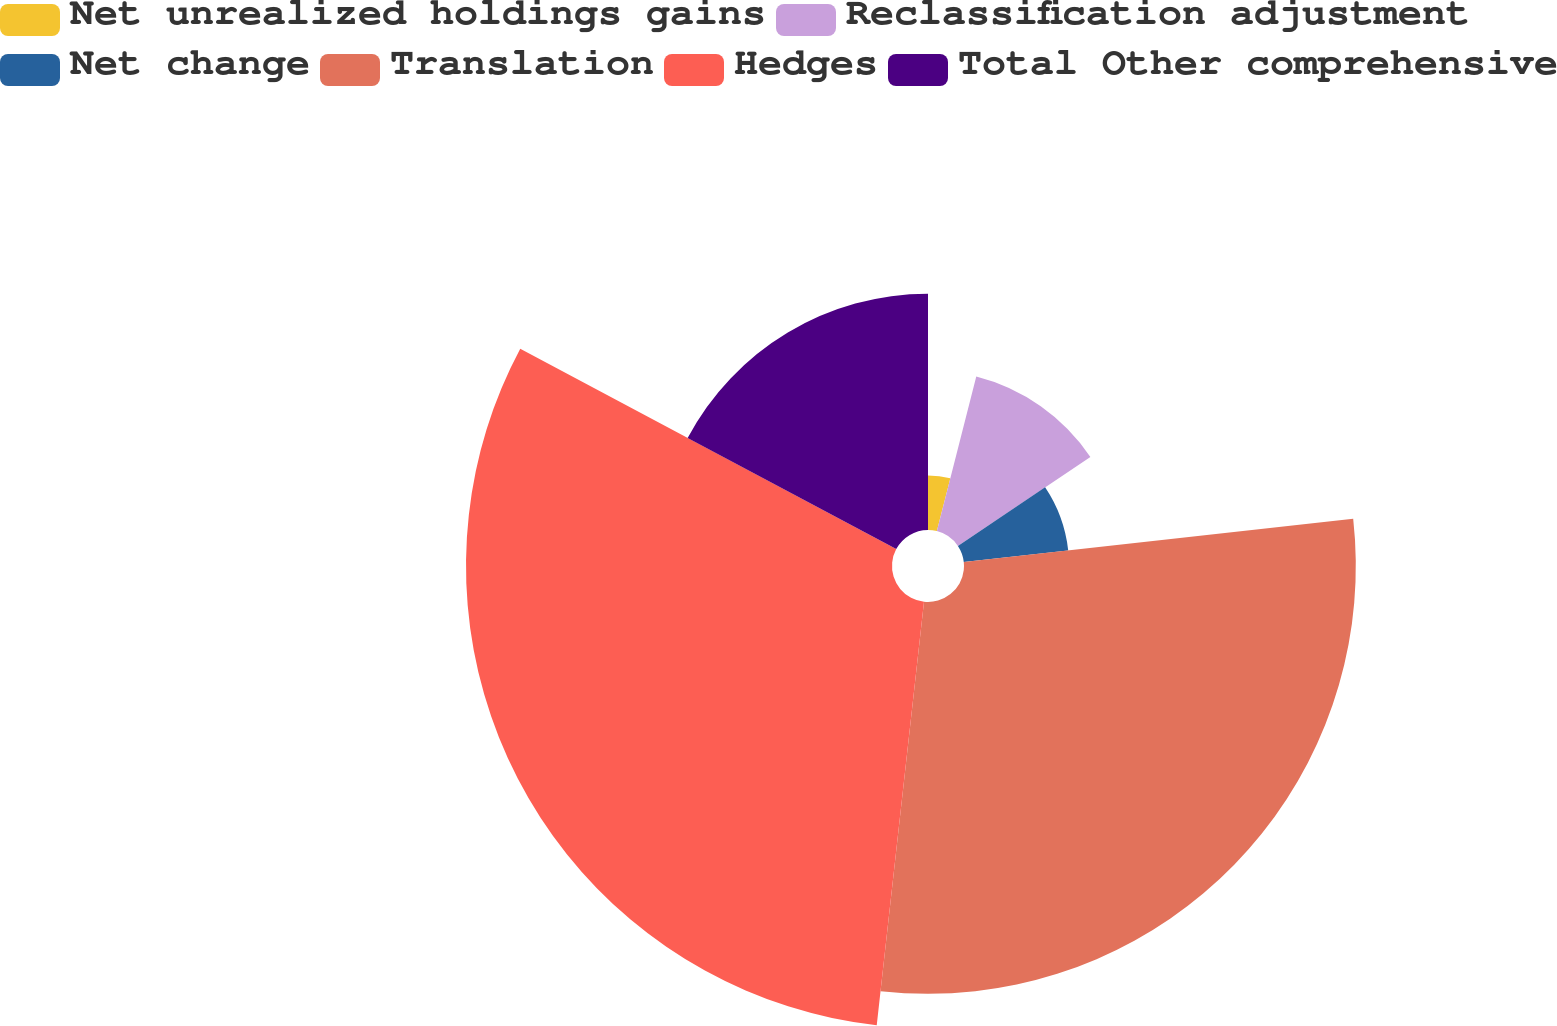Convert chart. <chart><loc_0><loc_0><loc_500><loc_500><pie_chart><fcel>Net unrealized holdings gains<fcel>Reclassification adjustment<fcel>Net change<fcel>Translation<fcel>Hedges<fcel>Total Other comprehensive<nl><fcel>3.97%<fcel>11.62%<fcel>7.65%<fcel>28.53%<fcel>31.02%<fcel>17.21%<nl></chart> 